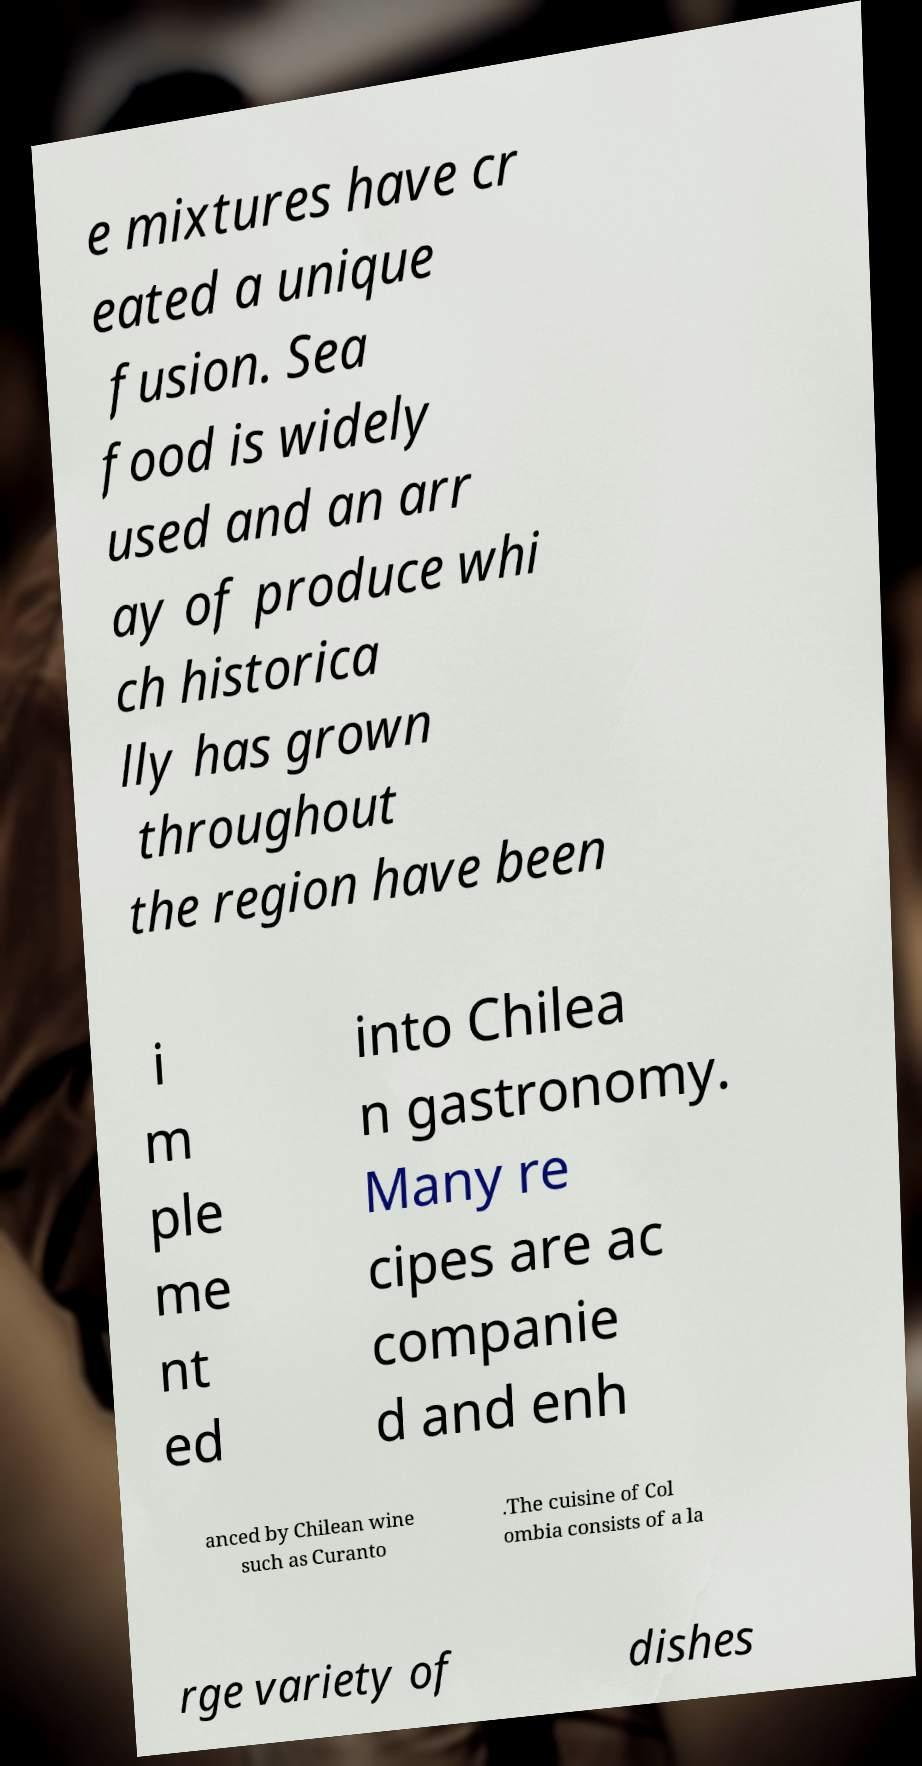Could you extract and type out the text from this image? e mixtures have cr eated a unique fusion. Sea food is widely used and an arr ay of produce whi ch historica lly has grown throughout the region have been i m ple me nt ed into Chilea n gastronomy. Many re cipes are ac companie d and enh anced by Chilean wine such as Curanto .The cuisine of Col ombia consists of a la rge variety of dishes 